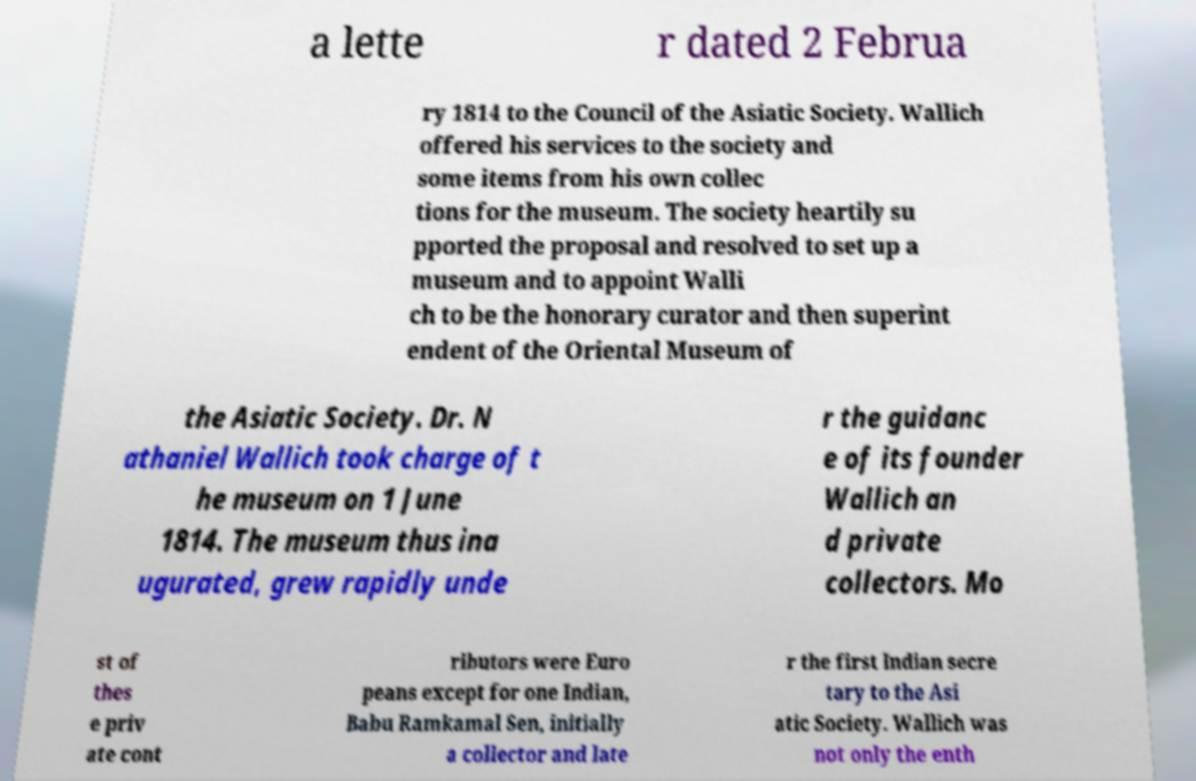What messages or text are displayed in this image? I need them in a readable, typed format. a lette r dated 2 Februa ry 1814 to the Council of the Asiatic Society. Wallich offered his services to the society and some items from his own collec tions for the museum. The society heartily su pported the proposal and resolved to set up a museum and to appoint Walli ch to be the honorary curator and then superint endent of the Oriental Museum of the Asiatic Society. Dr. N athaniel Wallich took charge of t he museum on 1 June 1814. The museum thus ina ugurated, grew rapidly unde r the guidanc e of its founder Wallich an d private collectors. Mo st of thes e priv ate cont ributors were Euro peans except for one Indian, Babu Ramkamal Sen, initially a collector and late r the first Indian secre tary to the Asi atic Society. Wallich was not only the enth 